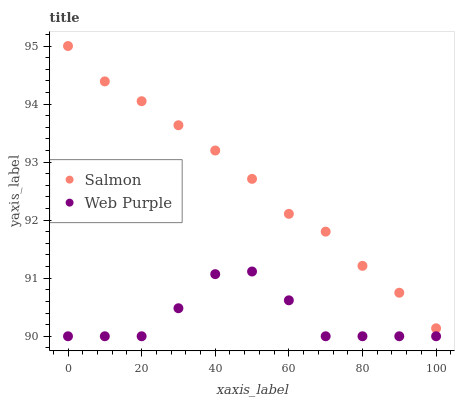Does Web Purple have the minimum area under the curve?
Answer yes or no. Yes. Does Salmon have the maximum area under the curve?
Answer yes or no. Yes. Does Salmon have the minimum area under the curve?
Answer yes or no. No. Is Salmon the smoothest?
Answer yes or no. Yes. Is Web Purple the roughest?
Answer yes or no. Yes. Is Salmon the roughest?
Answer yes or no. No. Does Web Purple have the lowest value?
Answer yes or no. Yes. Does Salmon have the lowest value?
Answer yes or no. No. Does Salmon have the highest value?
Answer yes or no. Yes. Is Web Purple less than Salmon?
Answer yes or no. Yes. Is Salmon greater than Web Purple?
Answer yes or no. Yes. Does Web Purple intersect Salmon?
Answer yes or no. No. 